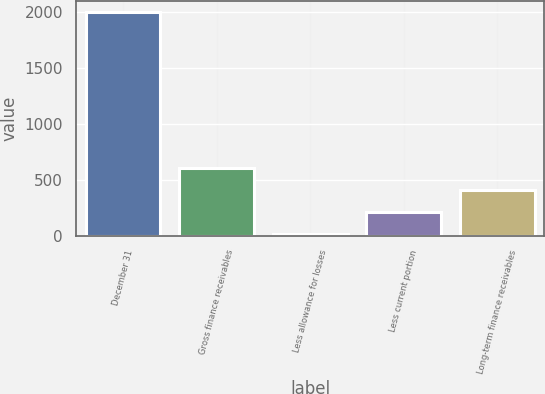<chart> <loc_0><loc_0><loc_500><loc_500><bar_chart><fcel>December 31<fcel>Gross finance receivables<fcel>Less allowance for losses<fcel>Less current portion<fcel>Long-term finance receivables<nl><fcel>2006<fcel>608.8<fcel>10<fcel>209.6<fcel>409.2<nl></chart> 